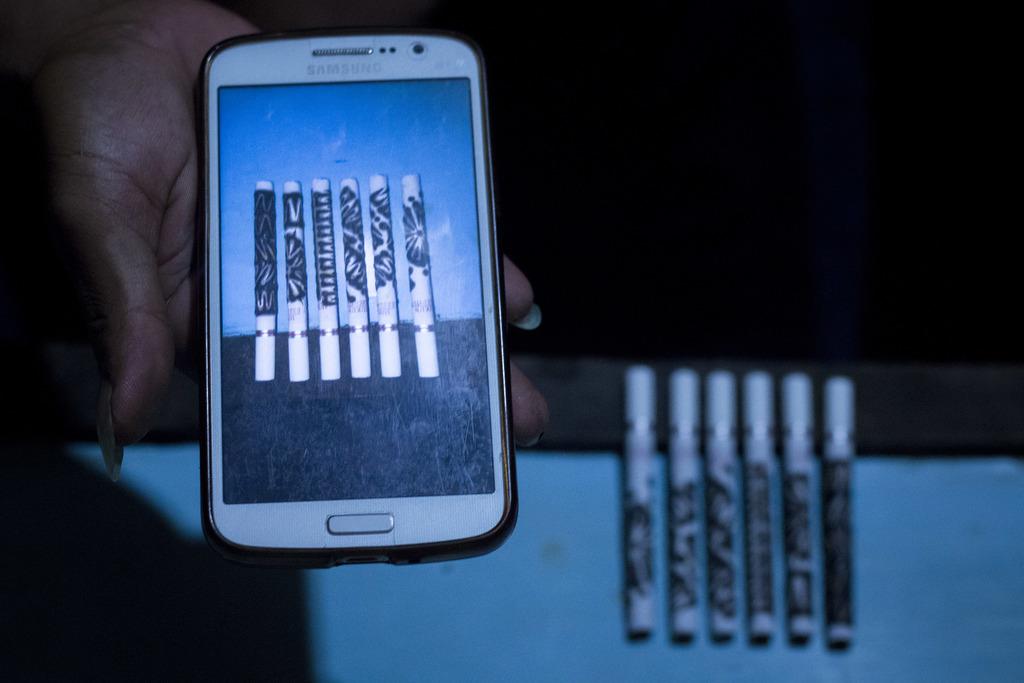What brand of phone is that?
Ensure brevity in your answer.  Samsung. 